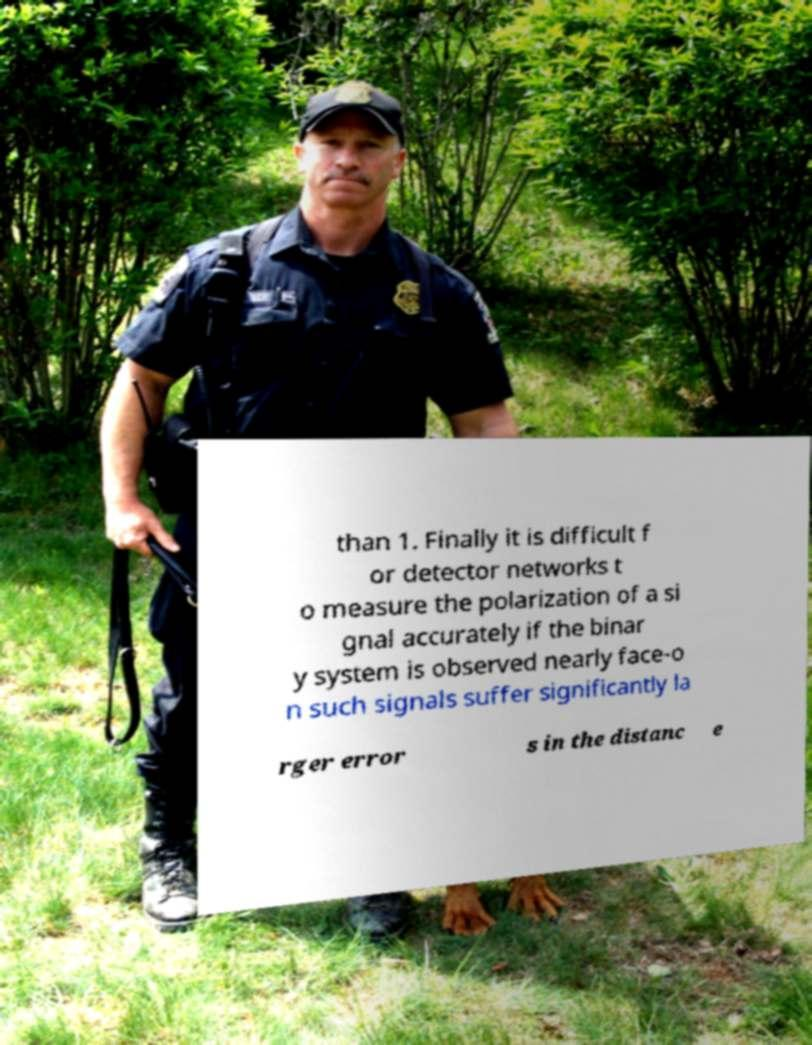Could you extract and type out the text from this image? than 1. Finally it is difficult f or detector networks t o measure the polarization of a si gnal accurately if the binar y system is observed nearly face-o n such signals suffer significantly la rger error s in the distanc e 